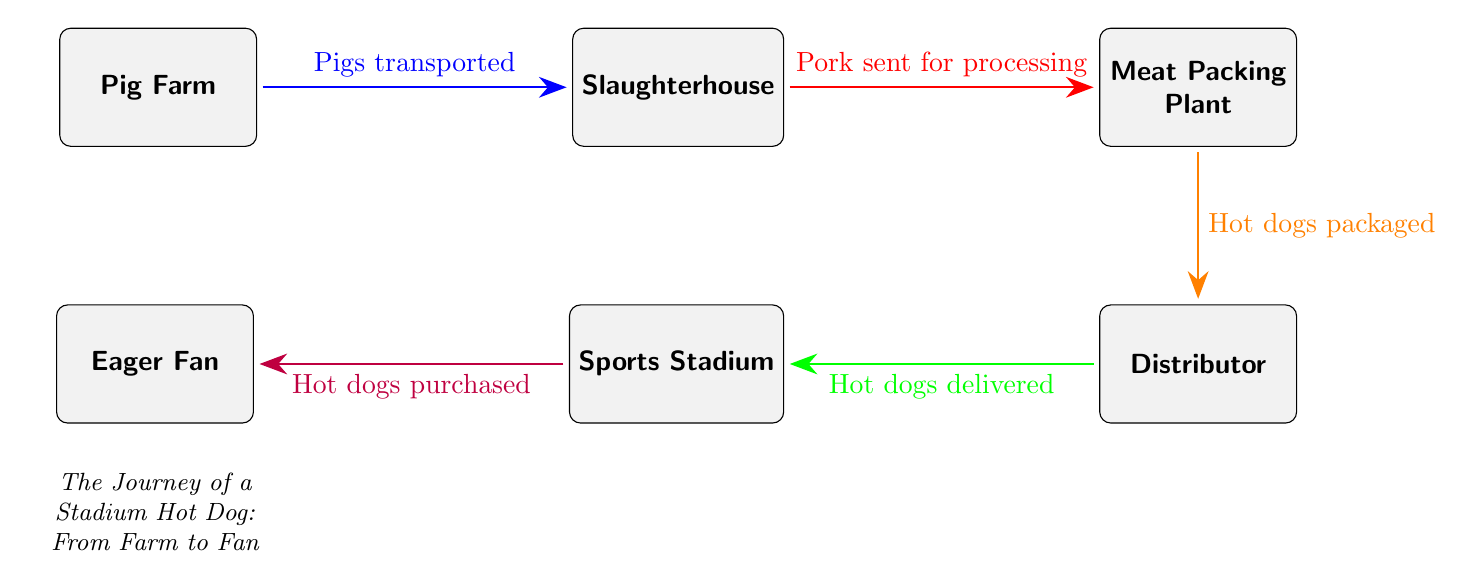What is the first location in the food chain? The diagram starts at the "Pig Farm," which is positioned at the leftmost part. This is where the process of producing hot dogs begins, as indicated by its placement in the food chain.
Answer: Pig Farm How many nodes are there in the food chain? Counting the nodes in the diagram, there are five distinct nodes: Pig Farm, Slaughterhouse, Meat Packing Plant, Distributor, and Sports Stadium. The "Eager Fan" is not counted as a production location but rather as the endpoint.
Answer: 5 What is transported from the farm to the slaughterhouse? According to the diagram, the flow points from the "Pig Farm" to the "Slaughterhouse" with the label "Pigs transported." This indicates that pigs, as the product of the farm, are moved to the next stage in the food chain.
Answer: Pigs What happens to the pork after it leaves the slaughterhouse? The arrow from "Slaughterhouse" to "Meat Packing Plant" is labeled "Pork sent for processing." This tells us that the pork is processed further at this stage, transitioning from livestock to packaged products.
Answer: Pork sent for processing Who buys the hot dogs at the end of the food chain? The final arrow leads from "Sports Stadium" to "Eager Fan," marked as "Hot dogs purchased." This clearly indicates that the "Eager Fan" is the one who buys and consumes the hot dogs after they are sold at the stadium.
Answer: Eager Fan What is packaged at the meat packing plant? The connection from "Meat Packing Plant" to "Distributor" is labeled "Hot dogs packaged." This indicates that the processing at the meat packing plant results in hot dogs being packaged for distribution.
Answer: Hot dogs What color represents the transportation of pigs? In the diagram, the transportation of pigs is represented by a blue arrow from "Pig Farm" to "Slaughterhouse." The color coding helps to visually distinguish the different stages and processes in the food chain.
Answer: Blue What is the last step in the journey of a hot dog? Following the flow in the diagram from "Sports Stadium" to "Eager Fan," the final action is indicated by the phrase "Hot dogs purchased." This shows that purchasing is the concluding action in the journey from farm to consumer.
Answer: Hot dogs purchased How are hot dogs delivered to the stadium? The connection between the "Distributor" and "Sports Stadium" is labeled "Hot dogs delivered." This label specifies that this step in the food chain involves the distribution of the hot dogs to the stadium venue.
Answer: Hot dogs delivered 